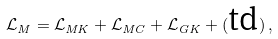Convert formula to latex. <formula><loc_0><loc_0><loc_500><loc_500>\mathcal { L } _ { M } = \mathcal { L } _ { M K } + \mathcal { L } _ { M C } + \mathcal { L } _ { G K } + ( \text {td} ) \, ,</formula> 